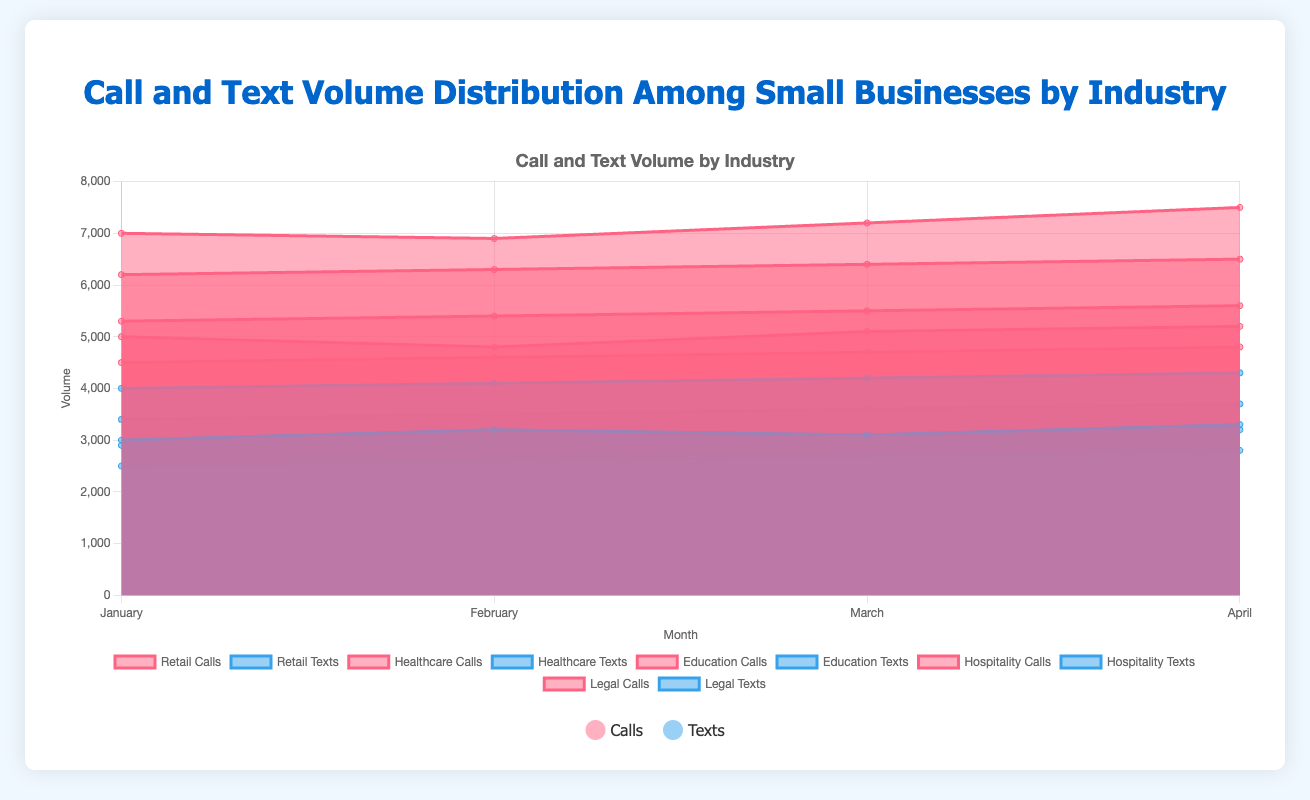What is the industry with the highest call volume in January? By looking at the chart, identify the industry section for January and compare the call volumes among different sectors. Healthcare industry shows the highest call volume at 7000.
Answer: Healthcare What is the total number of texts sent by the Hospitality industry from January to April? Sum the text volumes for the Hospitality industry across the four months: 2900 (Jan) + 3000 (Feb) + 3100 (Mar) + 3200 (Apr). This totals to 12200 texts.
Answer: 12200 Which month saw the highest call volume in the Legal industry? Look at the Legal industry's call volumes for each month. Identify the highest value among January (6200), February (6300), March (6400), and April (6500). April has the highest call volume at 6500.
Answer: April By how much did the Education industry's text volume increase from January to April? Subtract the text volume in January (2500) from the volume in April (2800). This is an increase of 300 texts.
Answer: 300 Which industry had the smallest overall text volume in March? Compare the text volumes of all industries in March: Retail (3100), Healthcare (4200), Education (2700), Hospitality (3100), and Legal (3600). The Education industry had the lowest text volume at 2700.
Answer: Education What is the average call volume for the Retail industry over the four months? Sum the call volumes for Retail: 5000 (Jan), 4800 (Feb), 5100 (Mar), 5200 (Apr). The total is 20100. Divide by 4 to get the average: 20100 / 4 = 5025.
Answer: 5025 How does the text volume of Retail in April compare to its call volume in the same month? Look at the values for Retail in April: Calls (5200) and Texts (3300). The call volume is greater than the text volume by 1900.
Answer: 1900 more calls What is the combined call volume of Retail and Hospitality in February? Sum the call volumes for Retail (4800) and Hospitality (5400) in February. The total is 4800 + 5400 = 10200.
Answer: 10200 Which industry shows the greatest increase in call volume from January to April? Calculate the increase for each industry from January to April and identify the largest: Retail (5200-5000=200), Healthcare (7500-7000=500), Education (4800-4500=300), Hospitality (5600-5300=300), Legal (6500-6200=300). Healthcare has the largest increase at 500.
Answer: Healthcare 